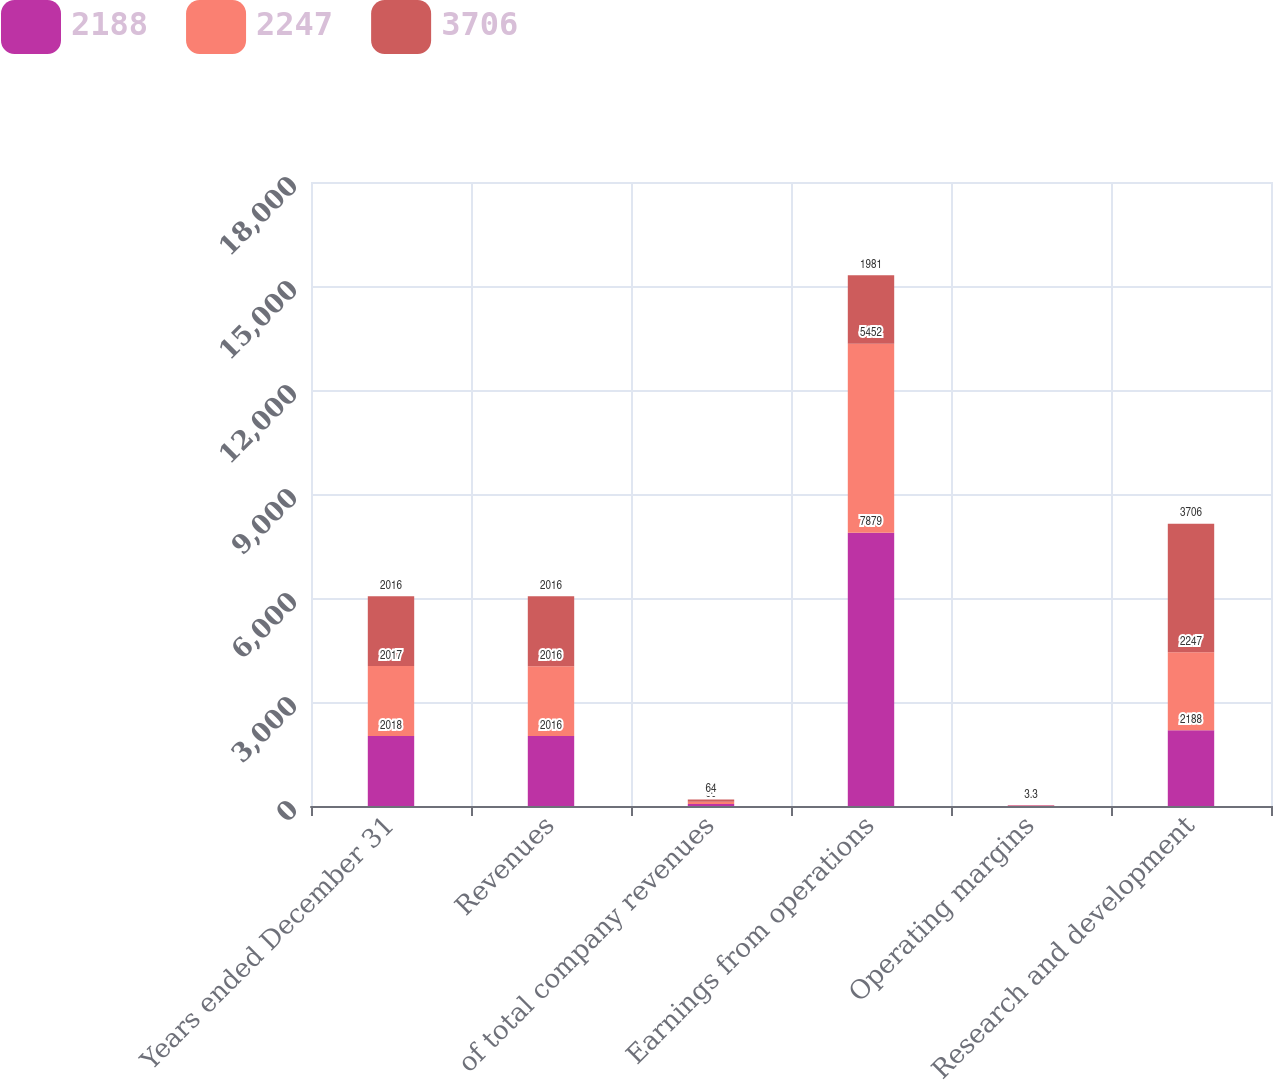Convert chart to OTSL. <chart><loc_0><loc_0><loc_500><loc_500><stacked_bar_chart><ecel><fcel>Years ended December 31<fcel>Revenues<fcel>of total company revenues<fcel>Earnings from operations<fcel>Operating margins<fcel>Research and development<nl><fcel>2188<fcel>2018<fcel>2016<fcel>60<fcel>7879<fcel>13<fcel>2188<nl><fcel>2247<fcel>2017<fcel>2016<fcel>62<fcel>5452<fcel>9.4<fcel>2247<nl><fcel>3706<fcel>2016<fcel>2016<fcel>64<fcel>1981<fcel>3.3<fcel>3706<nl></chart> 